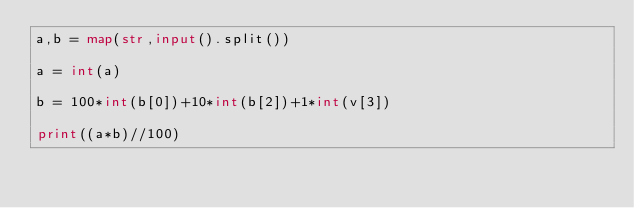<code> <loc_0><loc_0><loc_500><loc_500><_Python_>a,b = map(str,input().split())

a = int(a)

b = 100*int(b[0])+10*int(b[2])+1*int(v[3])

print((a*b)//100)
</code> 